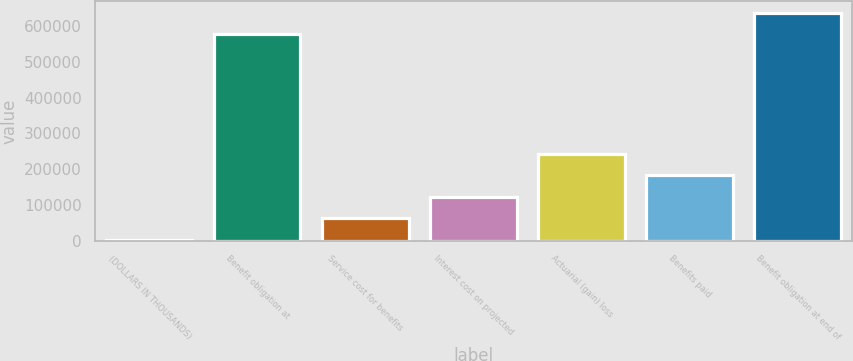<chart> <loc_0><loc_0><loc_500><loc_500><bar_chart><fcel>(DOLLARS IN THOUSANDS)<fcel>Benefit obligation at<fcel>Service cost for benefits<fcel>Interest cost on projected<fcel>Actuarial (gain) loss<fcel>Benefits paid<fcel>Benefit obligation at end of<nl><fcel>2017<fcel>577332<fcel>62093.6<fcel>122170<fcel>242323<fcel>182247<fcel>637409<nl></chart> 